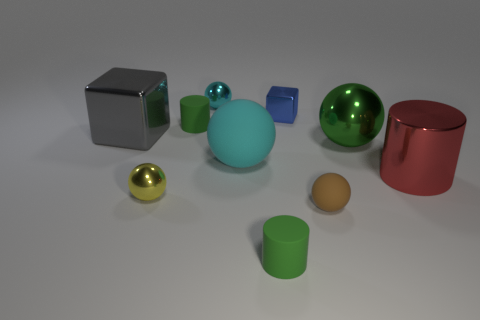How many other things are there of the same material as the large cube?
Provide a short and direct response. 5. Is the number of cyan spheres that are in front of the small blue shiny cube less than the number of tiny rubber things on the left side of the brown sphere?
Keep it short and to the point. Yes. There is another rubber object that is the same shape as the brown rubber object; what color is it?
Your response must be concise. Cyan. There is a green cylinder in front of the brown matte object; does it have the same size as the small metal block?
Offer a very short reply. Yes. Are there fewer green metal objects to the right of the big red shiny cylinder than cyan metallic objects?
Keep it short and to the point. Yes. What size is the gray object that is to the left of the green matte cylinder behind the tiny brown matte thing?
Your answer should be compact. Large. Is the number of big purple rubber things less than the number of tiny metal blocks?
Give a very brief answer. Yes. There is a thing that is both left of the tiny brown ball and in front of the yellow shiny sphere; what material is it?
Provide a short and direct response. Rubber. There is a green thing behind the large green sphere; is there a cylinder in front of it?
Make the answer very short. Yes. What number of objects are either green spheres or tiny blue blocks?
Your answer should be compact. 2. 